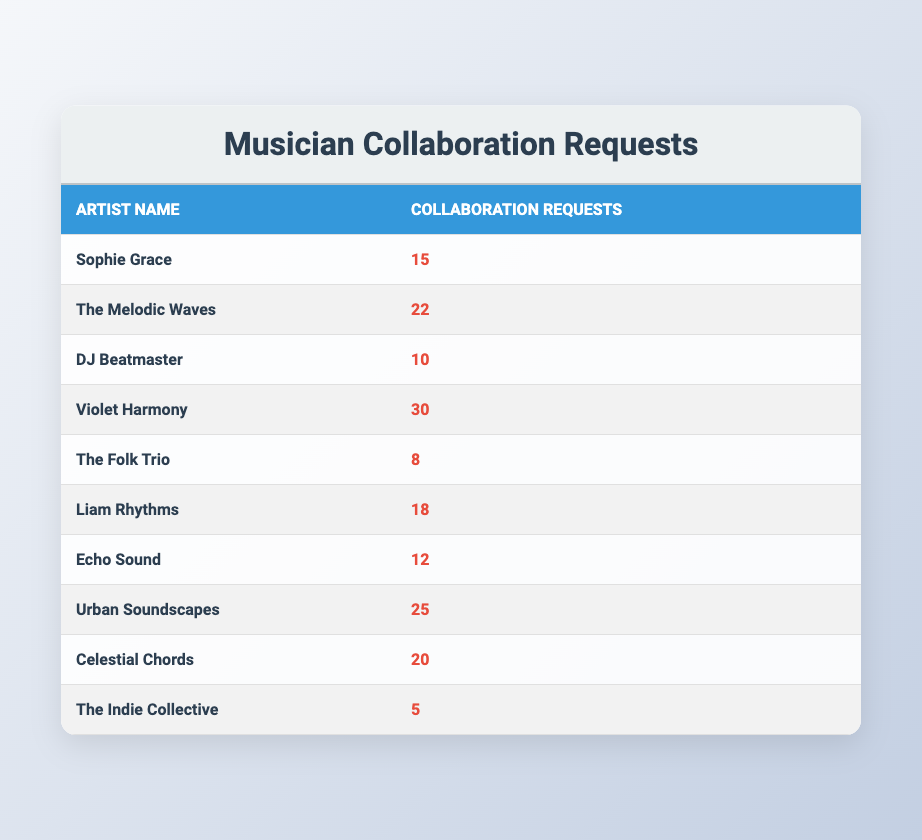What is the highest number of collaboration requests received by an artist? The table lists the collaboration requests received by each artist. The highest number is found under "Violet Harmony," which has 30 requests.
Answer: 30 Which artist received the least collaboration requests? By looking at the requests, "The Indie Collective" has the lowest entry with only 5 requests, making it the artist with the fewest.
Answer: The Indie Collective Calculate the total number of collaboration requests received by all artists. To find the total, add up all the individual requests: 15 + 22 + 10 + 30 + 8 + 18 + 12 + 25 + 20 + 5 =  10 + 30 + 8 + 18 + 12 + 25 + 20 + 5 = 165.
Answer: 165 Are there more artists with more than 15 collaboration requests or artists with 15 requests or fewer? Counting the requests, there are 6 artists who have more than 15 requests (The Melodic Waves, Violet Harmony, Urban Soundscapes, Celestial Chords, Liam Rhythms, and Sophie Grace) compared to 4 artists with 15 requests or fewer. Thus, there are more artists with over 15 requests.
Answer: Yes What is the average number of collaboration requests received by the artists? The average is calculated by taking the total requests (165) and dividing by the number of artists (10). Therefore, average = 165/10 = 16.5, indicating how many requests each artist would average if they were distributed evenly.
Answer: 16.5 